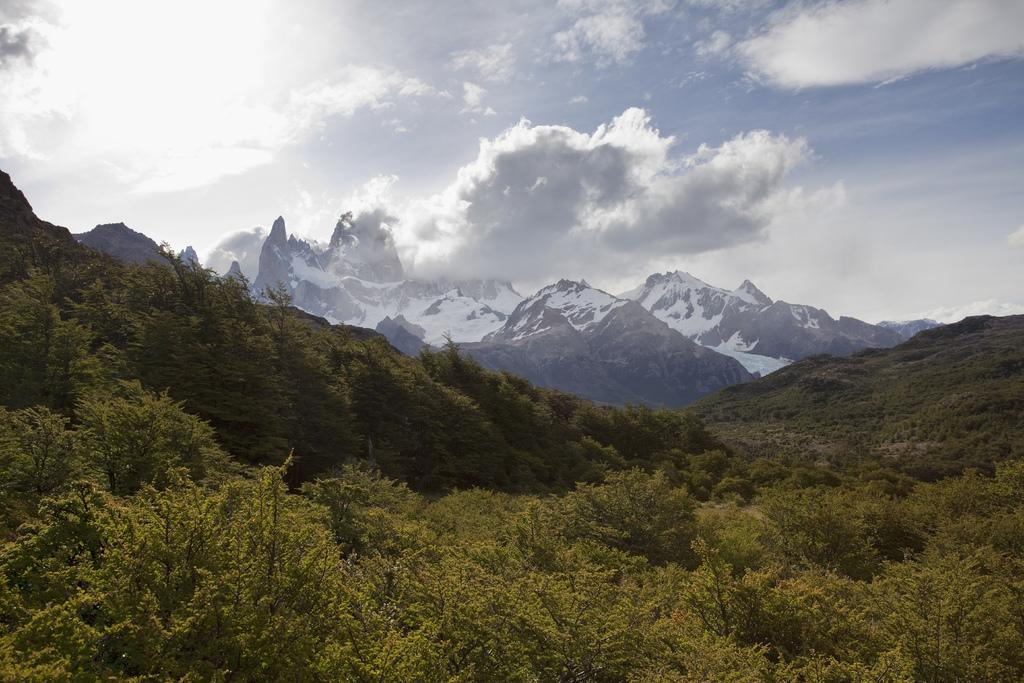What type of natural features can be seen in the image? There are trees and mountains in the image. What part of the natural environment is visible in the image? The sky is visible in the image. What type of toothbrush is hanging from the tree in the image? There is no toothbrush present in the image; it features trees, mountains, and the sky. 